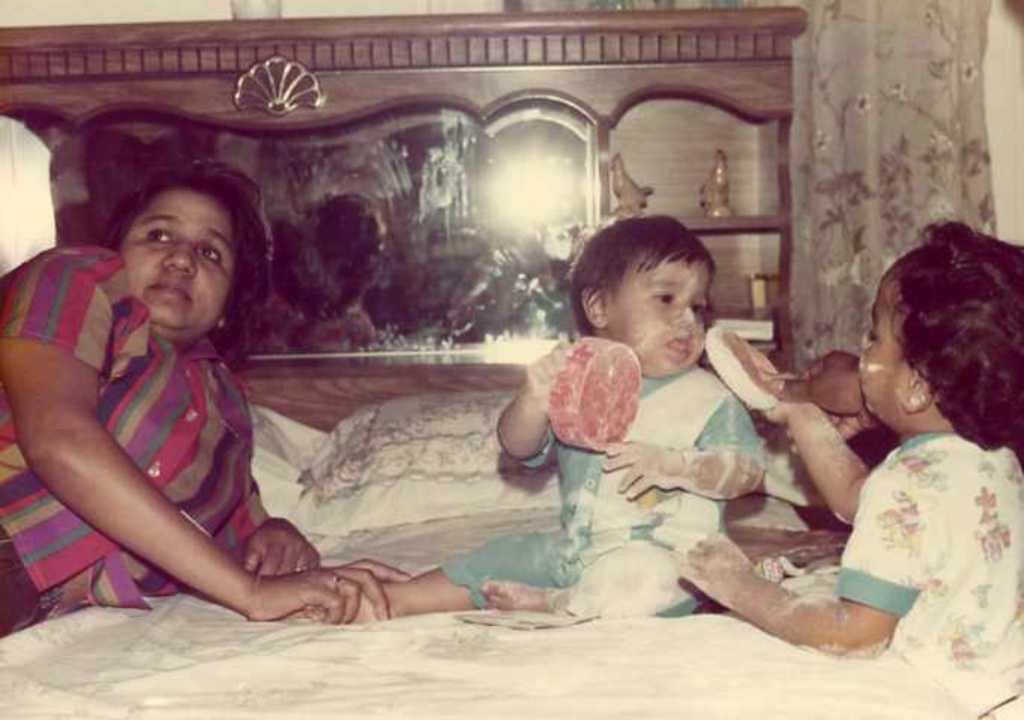How many people are on the bed in the image? There are three persons on the bed in the image. What can be found on the bed besides the people? There are pillows on the bed. What are the kids holding in the image? Two kids are holding objects in the image. Where are the toys located in the room? The toys are in the cupboards in the room. What type of window treatment is visible in the image? There are curtains visible in the image. What type of canvas is being painted by the men in the image? There are no men or canvas present in the image. How many letters are visible on the bed in the image? There are no letters visible on the bed in the image. 